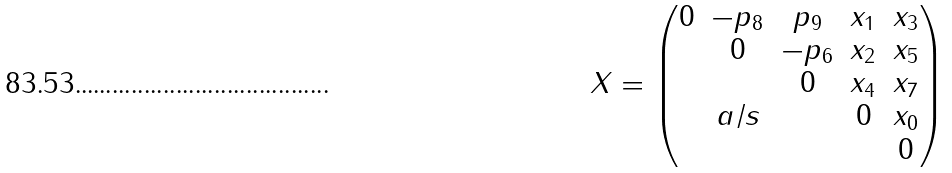Convert formula to latex. <formula><loc_0><loc_0><loc_500><loc_500>X = \begin{pmatrix} 0 & - p _ { 8 } & p _ { 9 } & x _ { 1 } & x _ { 3 } \\ & 0 & - p _ { 6 } & x _ { 2 } & x _ { 5 } \\ & & 0 & x _ { 4 } & x _ { 7 } \\ & a / s & & 0 & x _ { 0 } \\ & & & & 0 \end{pmatrix}</formula> 